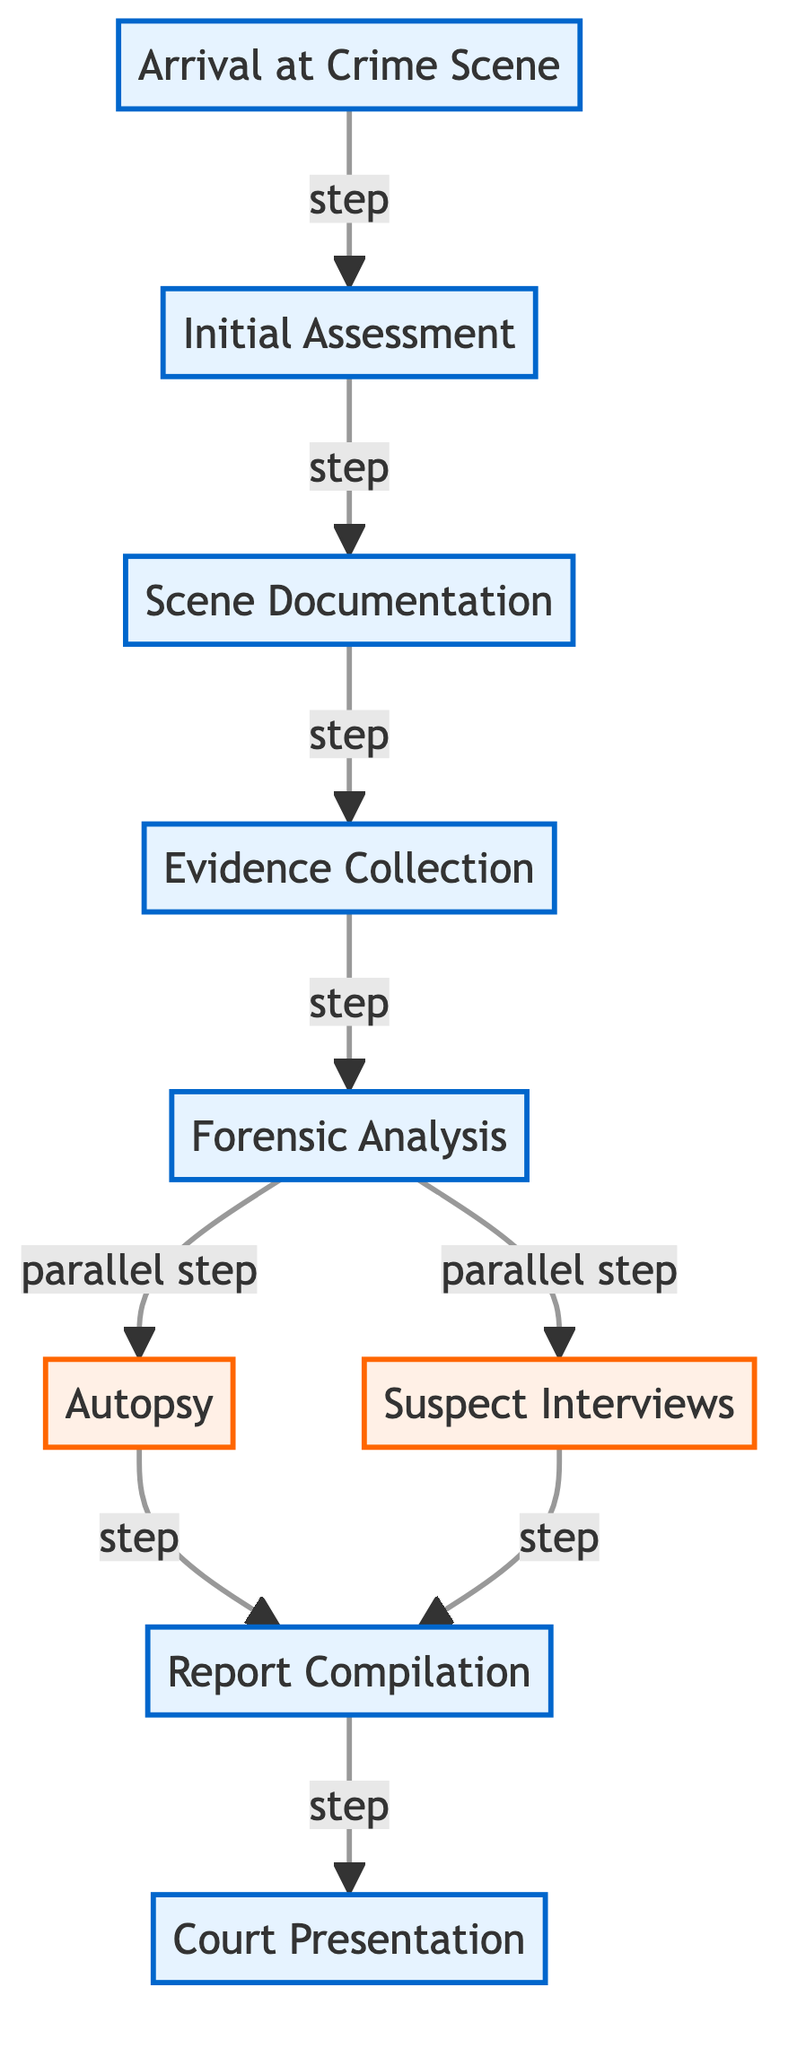What is the first step in the crime scene investigation process? The diagram directly indicates that the first step is "Arrival at Crime Scene." This is the initial action that triggers the entire investigation process.
Answer: Arrival at Crime Scene How many parallel steps are present in the diagram? By examining the flow, there are two distinct parallel steps: "Autopsy" and "Suspect Interviews." Both occur concurrently after "Forensic Analysis."
Answer: 2 What step follows evidence collection? The arrow following "Evidence Collection" clearly indicates the next step is "Forensic Analysis." This sequence shows that once evidence is collected, it proceeds to be analyzed.
Answer: Forensic Analysis After the forensic analysis, which steps can occur simultaneously? The diagram shows that after "Forensic Analysis," both "Autopsy" and "Suspect Interviews" can occur at the same time, as they are depicted as parallel steps following this node.
Answer: Autopsy and Suspect Interviews What is the last step in the crime scene investigation process? The diagram points to "Court Presentation" as the final step in the process, signifying that all prior investigations lead up to this presentation in court.
Answer: Court Presentation How does "Scene Documentation" relate to "Initial Assessment"? The flowchart demonstrates a linear connection from "Initial Assessment" to "Scene Documentation," indicating that documentation is conducted after assessing the scene, showing the progression of the investigation.
Answer: Scene Documentation follows Initial Assessment What step must occur before preparing a report? According to the diagram, both "Forensic Analysis" and "Suspect Interviews" must occur before moving on to "Report Compilation," as indicated by the arrows leading into it.
Answer: Forensic Analysis and Suspect Interviews What is the relationship between "Forensic Analysis" and the other steps? "Forensic Analysis" serves as a critical point, leading to two parallel steps: "Autopsy" and "Suspect Interviews." This indicates its centrality in the investigation before compiling the report.
Answer: Central node leading to parallel steps How many total steps are outlined in this crime scene investigation process? Counting all the steps listed in the diagram yields a total of nine distinct steps, providing a comprehensive overview of the entire crime investigation journey.
Answer: 9 